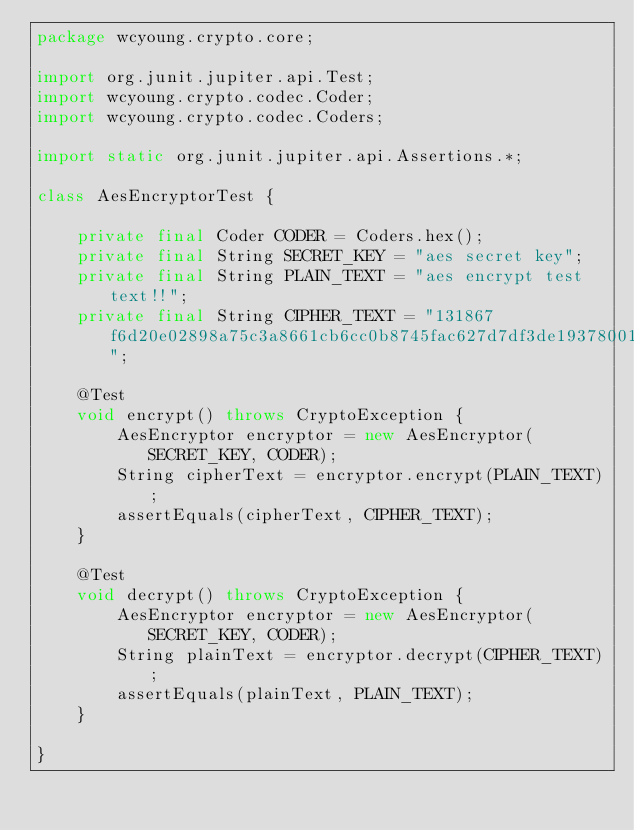<code> <loc_0><loc_0><loc_500><loc_500><_Java_>package wcyoung.crypto.core;

import org.junit.jupiter.api.Test;
import wcyoung.crypto.codec.Coder;
import wcyoung.crypto.codec.Coders;

import static org.junit.jupiter.api.Assertions.*;

class AesEncryptorTest {

    private final Coder CODER = Coders.hex();
    private final String SECRET_KEY = "aes secret key";
    private final String PLAIN_TEXT = "aes encrypt test text!!";
    private final String CIPHER_TEXT = "131867f6d20e02898a75c3a8661cb6cc0b8745fac627d7df3de19378001995fb";

    @Test
    void encrypt() throws CryptoException {
        AesEncryptor encryptor = new AesEncryptor(SECRET_KEY, CODER);
        String cipherText = encryptor.encrypt(PLAIN_TEXT);
        assertEquals(cipherText, CIPHER_TEXT);
    }

    @Test
    void decrypt() throws CryptoException {
        AesEncryptor encryptor = new AesEncryptor(SECRET_KEY, CODER);
        String plainText = encryptor.decrypt(CIPHER_TEXT);
        assertEquals(plainText, PLAIN_TEXT);
    }

}</code> 